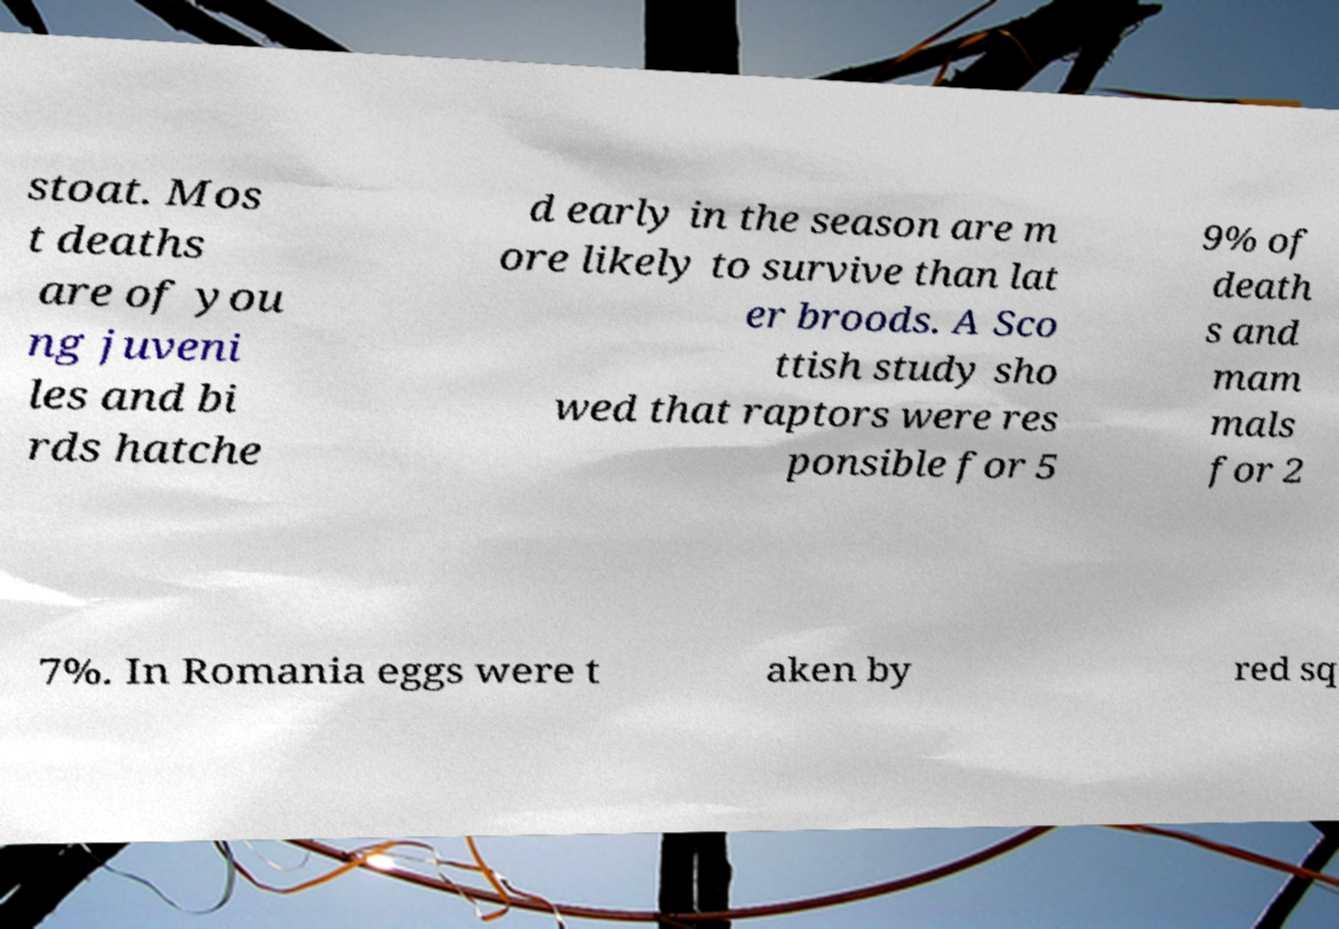Can you read and provide the text displayed in the image?This photo seems to have some interesting text. Can you extract and type it out for me? stoat. Mos t deaths are of you ng juveni les and bi rds hatche d early in the season are m ore likely to survive than lat er broods. A Sco ttish study sho wed that raptors were res ponsible for 5 9% of death s and mam mals for 2 7%. In Romania eggs were t aken by red sq 